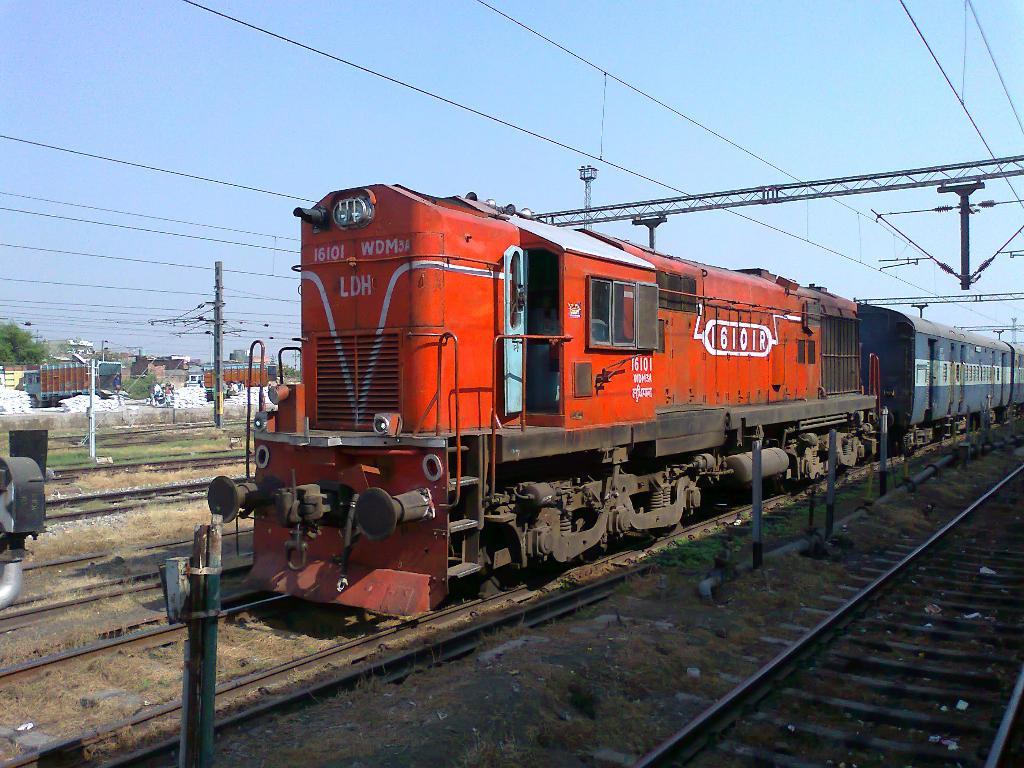What number train is this?
Your answer should be very brief. 16101. 